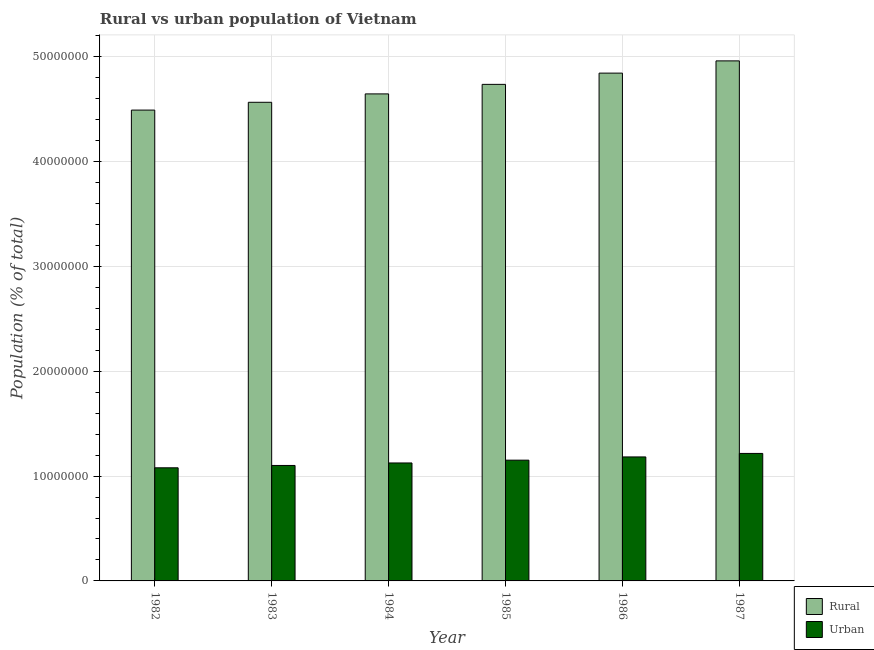Are the number of bars per tick equal to the number of legend labels?
Give a very brief answer. Yes. Are the number of bars on each tick of the X-axis equal?
Make the answer very short. Yes. How many bars are there on the 6th tick from the left?
Provide a succinct answer. 2. What is the rural population density in 1987?
Your answer should be very brief. 4.96e+07. Across all years, what is the maximum urban population density?
Your answer should be compact. 1.22e+07. Across all years, what is the minimum urban population density?
Your response must be concise. 1.08e+07. In which year was the rural population density minimum?
Your answer should be very brief. 1982. What is the total rural population density in the graph?
Make the answer very short. 2.82e+08. What is the difference between the urban population density in 1984 and that in 1986?
Provide a succinct answer. -5.75e+05. What is the difference between the rural population density in 1986 and the urban population density in 1985?
Offer a very short reply. 1.07e+06. What is the average urban population density per year?
Offer a terse response. 1.14e+07. What is the ratio of the urban population density in 1984 to that in 1987?
Provide a short and direct response. 0.93. Is the difference between the urban population density in 1985 and 1986 greater than the difference between the rural population density in 1985 and 1986?
Offer a terse response. No. What is the difference between the highest and the second highest urban population density?
Ensure brevity in your answer.  3.33e+05. What is the difference between the highest and the lowest rural population density?
Provide a succinct answer. 4.69e+06. In how many years, is the rural population density greater than the average rural population density taken over all years?
Your answer should be compact. 3. Is the sum of the rural population density in 1984 and 1986 greater than the maximum urban population density across all years?
Your answer should be compact. Yes. What does the 1st bar from the left in 1987 represents?
Your answer should be very brief. Rural. What does the 2nd bar from the right in 1984 represents?
Provide a short and direct response. Rural. Are all the bars in the graph horizontal?
Offer a terse response. No. How many years are there in the graph?
Your answer should be compact. 6. Are the values on the major ticks of Y-axis written in scientific E-notation?
Your answer should be very brief. No. Does the graph contain any zero values?
Your answer should be very brief. No. Does the graph contain grids?
Offer a terse response. Yes. Where does the legend appear in the graph?
Offer a very short reply. Bottom right. How many legend labels are there?
Ensure brevity in your answer.  2. What is the title of the graph?
Ensure brevity in your answer.  Rural vs urban population of Vietnam. Does "Methane emissions" appear as one of the legend labels in the graph?
Offer a terse response. No. What is the label or title of the Y-axis?
Your answer should be very brief. Population (% of total). What is the Population (% of total) in Rural in 1982?
Your response must be concise. 4.49e+07. What is the Population (% of total) of Urban in 1982?
Provide a succinct answer. 1.08e+07. What is the Population (% of total) of Rural in 1983?
Your answer should be compact. 4.56e+07. What is the Population (% of total) in Urban in 1983?
Give a very brief answer. 1.10e+07. What is the Population (% of total) in Rural in 1984?
Provide a short and direct response. 4.64e+07. What is the Population (% of total) in Urban in 1984?
Offer a very short reply. 1.12e+07. What is the Population (% of total) in Rural in 1985?
Give a very brief answer. 4.74e+07. What is the Population (% of total) of Urban in 1985?
Provide a short and direct response. 1.15e+07. What is the Population (% of total) of Rural in 1986?
Ensure brevity in your answer.  4.84e+07. What is the Population (% of total) of Urban in 1986?
Ensure brevity in your answer.  1.18e+07. What is the Population (% of total) in Rural in 1987?
Ensure brevity in your answer.  4.96e+07. What is the Population (% of total) in Urban in 1987?
Your response must be concise. 1.22e+07. Across all years, what is the maximum Population (% of total) in Rural?
Your answer should be compact. 4.96e+07. Across all years, what is the maximum Population (% of total) of Urban?
Your response must be concise. 1.22e+07. Across all years, what is the minimum Population (% of total) in Rural?
Keep it short and to the point. 4.49e+07. Across all years, what is the minimum Population (% of total) in Urban?
Your answer should be compact. 1.08e+07. What is the total Population (% of total) of Rural in the graph?
Provide a succinct answer. 2.82e+08. What is the total Population (% of total) of Urban in the graph?
Your response must be concise. 6.85e+07. What is the difference between the Population (% of total) in Rural in 1982 and that in 1983?
Your answer should be compact. -7.45e+05. What is the difference between the Population (% of total) in Urban in 1982 and that in 1983?
Provide a succinct answer. -2.23e+05. What is the difference between the Population (% of total) of Rural in 1982 and that in 1984?
Make the answer very short. -1.54e+06. What is the difference between the Population (% of total) of Urban in 1982 and that in 1984?
Provide a succinct answer. -4.61e+05. What is the difference between the Population (% of total) in Rural in 1982 and that in 1985?
Ensure brevity in your answer.  -2.45e+06. What is the difference between the Population (% of total) of Urban in 1982 and that in 1985?
Provide a short and direct response. -7.27e+05. What is the difference between the Population (% of total) in Rural in 1982 and that in 1986?
Ensure brevity in your answer.  -3.53e+06. What is the difference between the Population (% of total) in Urban in 1982 and that in 1986?
Give a very brief answer. -1.04e+06. What is the difference between the Population (% of total) in Rural in 1982 and that in 1987?
Your answer should be compact. -4.69e+06. What is the difference between the Population (% of total) in Urban in 1982 and that in 1987?
Provide a short and direct response. -1.37e+06. What is the difference between the Population (% of total) of Rural in 1983 and that in 1984?
Provide a succinct answer. -7.99e+05. What is the difference between the Population (% of total) of Urban in 1983 and that in 1984?
Your answer should be very brief. -2.38e+05. What is the difference between the Population (% of total) of Rural in 1983 and that in 1985?
Your answer should be compact. -1.71e+06. What is the difference between the Population (% of total) of Urban in 1983 and that in 1985?
Provide a succinct answer. -5.04e+05. What is the difference between the Population (% of total) of Rural in 1983 and that in 1986?
Offer a terse response. -2.78e+06. What is the difference between the Population (% of total) in Urban in 1983 and that in 1986?
Your answer should be compact. -8.13e+05. What is the difference between the Population (% of total) in Rural in 1983 and that in 1987?
Ensure brevity in your answer.  -3.95e+06. What is the difference between the Population (% of total) of Urban in 1983 and that in 1987?
Offer a terse response. -1.15e+06. What is the difference between the Population (% of total) of Rural in 1984 and that in 1985?
Your response must be concise. -9.10e+05. What is the difference between the Population (% of total) of Urban in 1984 and that in 1985?
Provide a short and direct response. -2.66e+05. What is the difference between the Population (% of total) of Rural in 1984 and that in 1986?
Offer a terse response. -1.98e+06. What is the difference between the Population (% of total) of Urban in 1984 and that in 1986?
Your answer should be compact. -5.75e+05. What is the difference between the Population (% of total) of Rural in 1984 and that in 1987?
Your answer should be compact. -3.15e+06. What is the difference between the Population (% of total) in Urban in 1984 and that in 1987?
Give a very brief answer. -9.09e+05. What is the difference between the Population (% of total) in Rural in 1985 and that in 1986?
Make the answer very short. -1.07e+06. What is the difference between the Population (% of total) in Urban in 1985 and that in 1986?
Offer a terse response. -3.09e+05. What is the difference between the Population (% of total) of Rural in 1985 and that in 1987?
Your response must be concise. -2.24e+06. What is the difference between the Population (% of total) in Urban in 1985 and that in 1987?
Make the answer very short. -6.42e+05. What is the difference between the Population (% of total) of Rural in 1986 and that in 1987?
Your answer should be compact. -1.17e+06. What is the difference between the Population (% of total) of Urban in 1986 and that in 1987?
Ensure brevity in your answer.  -3.33e+05. What is the difference between the Population (% of total) in Rural in 1982 and the Population (% of total) in Urban in 1983?
Your answer should be very brief. 3.39e+07. What is the difference between the Population (% of total) of Rural in 1982 and the Population (% of total) of Urban in 1984?
Provide a short and direct response. 3.37e+07. What is the difference between the Population (% of total) in Rural in 1982 and the Population (% of total) in Urban in 1985?
Keep it short and to the point. 3.34e+07. What is the difference between the Population (% of total) in Rural in 1982 and the Population (% of total) in Urban in 1986?
Provide a succinct answer. 3.31e+07. What is the difference between the Population (% of total) in Rural in 1982 and the Population (% of total) in Urban in 1987?
Offer a terse response. 3.27e+07. What is the difference between the Population (% of total) of Rural in 1983 and the Population (% of total) of Urban in 1984?
Provide a succinct answer. 3.44e+07. What is the difference between the Population (% of total) of Rural in 1983 and the Population (% of total) of Urban in 1985?
Offer a terse response. 3.41e+07. What is the difference between the Population (% of total) in Rural in 1983 and the Population (% of total) in Urban in 1986?
Your answer should be very brief. 3.38e+07. What is the difference between the Population (% of total) of Rural in 1983 and the Population (% of total) of Urban in 1987?
Ensure brevity in your answer.  3.35e+07. What is the difference between the Population (% of total) of Rural in 1984 and the Population (% of total) of Urban in 1985?
Offer a very short reply. 3.49e+07. What is the difference between the Population (% of total) of Rural in 1984 and the Population (% of total) of Urban in 1986?
Your response must be concise. 3.46e+07. What is the difference between the Population (% of total) in Rural in 1984 and the Population (% of total) in Urban in 1987?
Keep it short and to the point. 3.43e+07. What is the difference between the Population (% of total) of Rural in 1985 and the Population (% of total) of Urban in 1986?
Ensure brevity in your answer.  3.55e+07. What is the difference between the Population (% of total) in Rural in 1985 and the Population (% of total) in Urban in 1987?
Offer a terse response. 3.52e+07. What is the difference between the Population (% of total) of Rural in 1986 and the Population (% of total) of Urban in 1987?
Offer a very short reply. 3.63e+07. What is the average Population (% of total) of Rural per year?
Offer a terse response. 4.71e+07. What is the average Population (% of total) in Urban per year?
Your answer should be very brief. 1.14e+07. In the year 1982, what is the difference between the Population (% of total) of Rural and Population (% of total) of Urban?
Provide a short and direct response. 3.41e+07. In the year 1983, what is the difference between the Population (% of total) of Rural and Population (% of total) of Urban?
Keep it short and to the point. 3.46e+07. In the year 1984, what is the difference between the Population (% of total) in Rural and Population (% of total) in Urban?
Offer a terse response. 3.52e+07. In the year 1985, what is the difference between the Population (% of total) of Rural and Population (% of total) of Urban?
Ensure brevity in your answer.  3.58e+07. In the year 1986, what is the difference between the Population (% of total) in Rural and Population (% of total) in Urban?
Offer a terse response. 3.66e+07. In the year 1987, what is the difference between the Population (% of total) of Rural and Population (% of total) of Urban?
Provide a short and direct response. 3.74e+07. What is the ratio of the Population (% of total) of Rural in 1982 to that in 1983?
Offer a very short reply. 0.98. What is the ratio of the Population (% of total) of Urban in 1982 to that in 1983?
Make the answer very short. 0.98. What is the ratio of the Population (% of total) of Rural in 1982 to that in 1984?
Ensure brevity in your answer.  0.97. What is the ratio of the Population (% of total) in Urban in 1982 to that in 1984?
Your response must be concise. 0.96. What is the ratio of the Population (% of total) in Rural in 1982 to that in 1985?
Your response must be concise. 0.95. What is the ratio of the Population (% of total) in Urban in 1982 to that in 1985?
Make the answer very short. 0.94. What is the ratio of the Population (% of total) of Rural in 1982 to that in 1986?
Your response must be concise. 0.93. What is the ratio of the Population (% of total) of Urban in 1982 to that in 1986?
Provide a short and direct response. 0.91. What is the ratio of the Population (% of total) in Rural in 1982 to that in 1987?
Keep it short and to the point. 0.91. What is the ratio of the Population (% of total) in Urban in 1982 to that in 1987?
Your answer should be very brief. 0.89. What is the ratio of the Population (% of total) in Rural in 1983 to that in 1984?
Your response must be concise. 0.98. What is the ratio of the Population (% of total) of Urban in 1983 to that in 1984?
Your response must be concise. 0.98. What is the ratio of the Population (% of total) in Rural in 1983 to that in 1985?
Keep it short and to the point. 0.96. What is the ratio of the Population (% of total) in Urban in 1983 to that in 1985?
Offer a very short reply. 0.96. What is the ratio of the Population (% of total) in Rural in 1983 to that in 1986?
Make the answer very short. 0.94. What is the ratio of the Population (% of total) of Urban in 1983 to that in 1986?
Offer a terse response. 0.93. What is the ratio of the Population (% of total) in Rural in 1983 to that in 1987?
Keep it short and to the point. 0.92. What is the ratio of the Population (% of total) of Urban in 1983 to that in 1987?
Your answer should be compact. 0.91. What is the ratio of the Population (% of total) of Rural in 1984 to that in 1985?
Give a very brief answer. 0.98. What is the ratio of the Population (% of total) in Urban in 1984 to that in 1985?
Offer a very short reply. 0.98. What is the ratio of the Population (% of total) of Rural in 1984 to that in 1986?
Keep it short and to the point. 0.96. What is the ratio of the Population (% of total) in Urban in 1984 to that in 1986?
Keep it short and to the point. 0.95. What is the ratio of the Population (% of total) in Rural in 1984 to that in 1987?
Make the answer very short. 0.94. What is the ratio of the Population (% of total) in Urban in 1984 to that in 1987?
Give a very brief answer. 0.93. What is the ratio of the Population (% of total) in Rural in 1985 to that in 1986?
Keep it short and to the point. 0.98. What is the ratio of the Population (% of total) in Urban in 1985 to that in 1986?
Offer a terse response. 0.97. What is the ratio of the Population (% of total) of Rural in 1985 to that in 1987?
Keep it short and to the point. 0.95. What is the ratio of the Population (% of total) of Urban in 1985 to that in 1987?
Offer a very short reply. 0.95. What is the ratio of the Population (% of total) of Rural in 1986 to that in 1987?
Your answer should be very brief. 0.98. What is the ratio of the Population (% of total) of Urban in 1986 to that in 1987?
Make the answer very short. 0.97. What is the difference between the highest and the second highest Population (% of total) of Rural?
Your response must be concise. 1.17e+06. What is the difference between the highest and the second highest Population (% of total) in Urban?
Make the answer very short. 3.33e+05. What is the difference between the highest and the lowest Population (% of total) in Rural?
Offer a terse response. 4.69e+06. What is the difference between the highest and the lowest Population (% of total) of Urban?
Provide a succinct answer. 1.37e+06. 